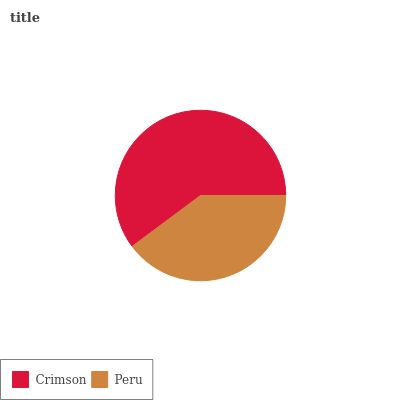Is Peru the minimum?
Answer yes or no. Yes. Is Crimson the maximum?
Answer yes or no. Yes. Is Peru the maximum?
Answer yes or no. No. Is Crimson greater than Peru?
Answer yes or no. Yes. Is Peru less than Crimson?
Answer yes or no. Yes. Is Peru greater than Crimson?
Answer yes or no. No. Is Crimson less than Peru?
Answer yes or no. No. Is Crimson the high median?
Answer yes or no. Yes. Is Peru the low median?
Answer yes or no. Yes. Is Peru the high median?
Answer yes or no. No. Is Crimson the low median?
Answer yes or no. No. 